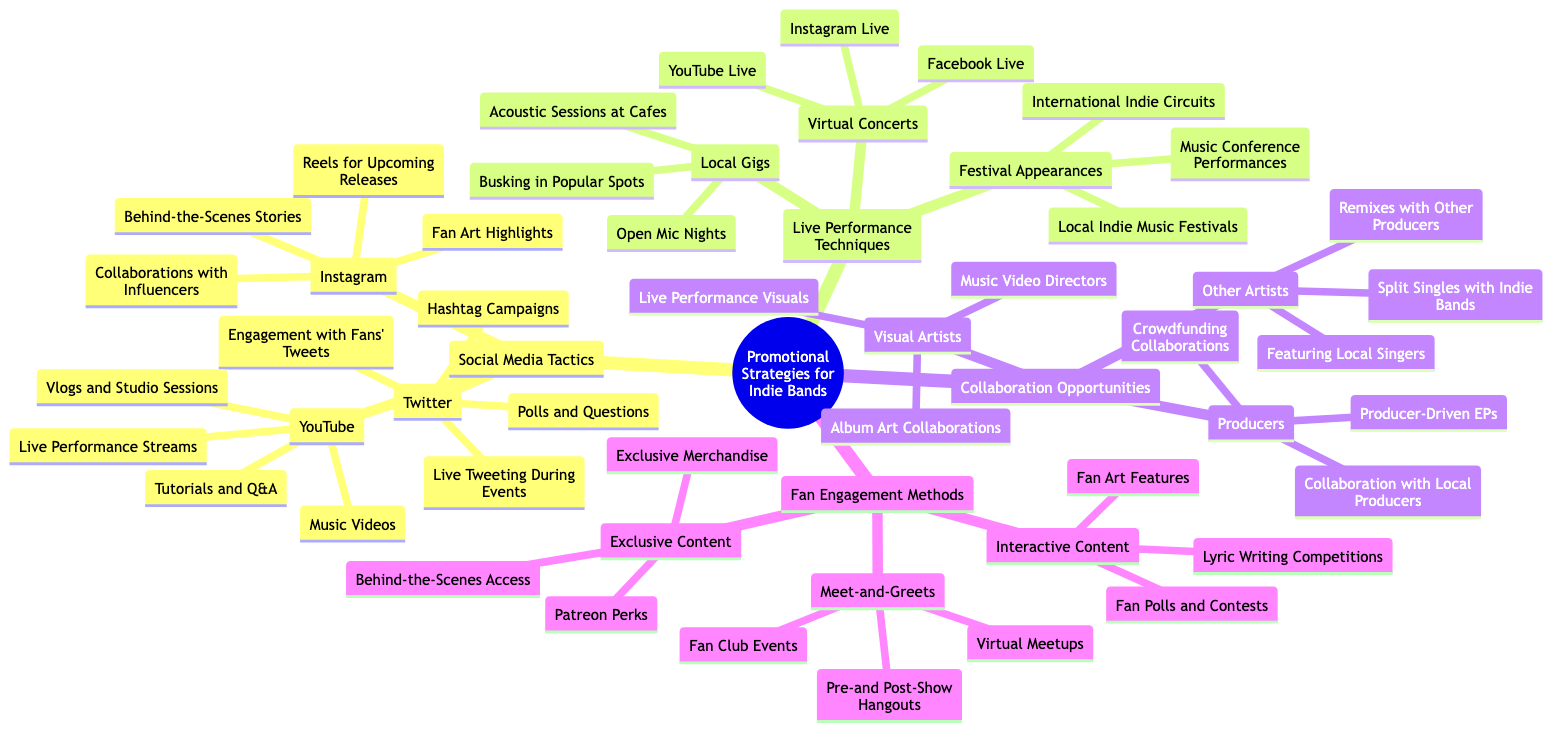What are the three social media platforms listed for promotion? The diagram outlines three social media platforms under "Social Media Tactics": Instagram, Twitter, and YouTube. This can be easily identified by tracing the connections from the main node to the sub-nodes under "Social Media Tactics."
Answer: Instagram, Twitter, YouTube How many types of local gigs are mentioned? Under "Live Performance Techniques," the "Local Gigs" node has three specific types listed: Open Mic Nights, Acoustic Sessions at Cafes, and Busking in Popular Spots. Counting these sub-nodes gives the total.
Answer: 3 What collaborations are suggested with visual artists? The diagram specifies three collaboration opportunities with visual artists under the "Collaboration Opportunities" section: Album Art Collaborations, Music Video Directors, and Live Performance Visuals. By examining the sub-nodes under "Visual Artists", we can find these items easily.
Answer: Album Art Collaborations, Music Video Directors, Live Performance Visuals Which social media platform includes tutorials and Q&A? The "YouTube" node under "Social Media Tactics" lists "Tutorials and Q&A" as one of its sub-nodes. By looking at the various branches under each platform, it's clear that YouTube features this content format specifically.
Answer: YouTube What are the engagement methods used for fan interactions? The "Fan Engagement Methods" section includes three main types of engagement: Exclusive Content, Meet-and-Greets, and Interactive Content. Each of these is a major node under "Fan Engagement Methods" and can be identified as distinct categories for engagement.
Answer: Exclusive Content, Meet-and-Greets, Interactive Content Which type of performances has "Facebook Live" as an option? "Facebook Live" is listed under the "Virtual Concerts" node in the "Live Performance Techniques" section. This can be determined by following the paths through the nodes categorizing performance types.
Answer: Virtual Concerts How many different types of interactive content are there? The "Interactive Content" node under "Fan Engagement Methods" includes three different types: Fan Polls and Contests, Lyric Writing Competitions, and Fan Art Features. By counting these sub-nodes, we obtain the quantity.
Answer: 3 What is the method of collaboration suggested with local producers? The node "Collaboration with Local Producers" is directly listed under the "Producers" category in "Collaboration Opportunities." It can be traced directly from the main topic to understand this collaboration method.
Answer: Collaboration with Local Producers 